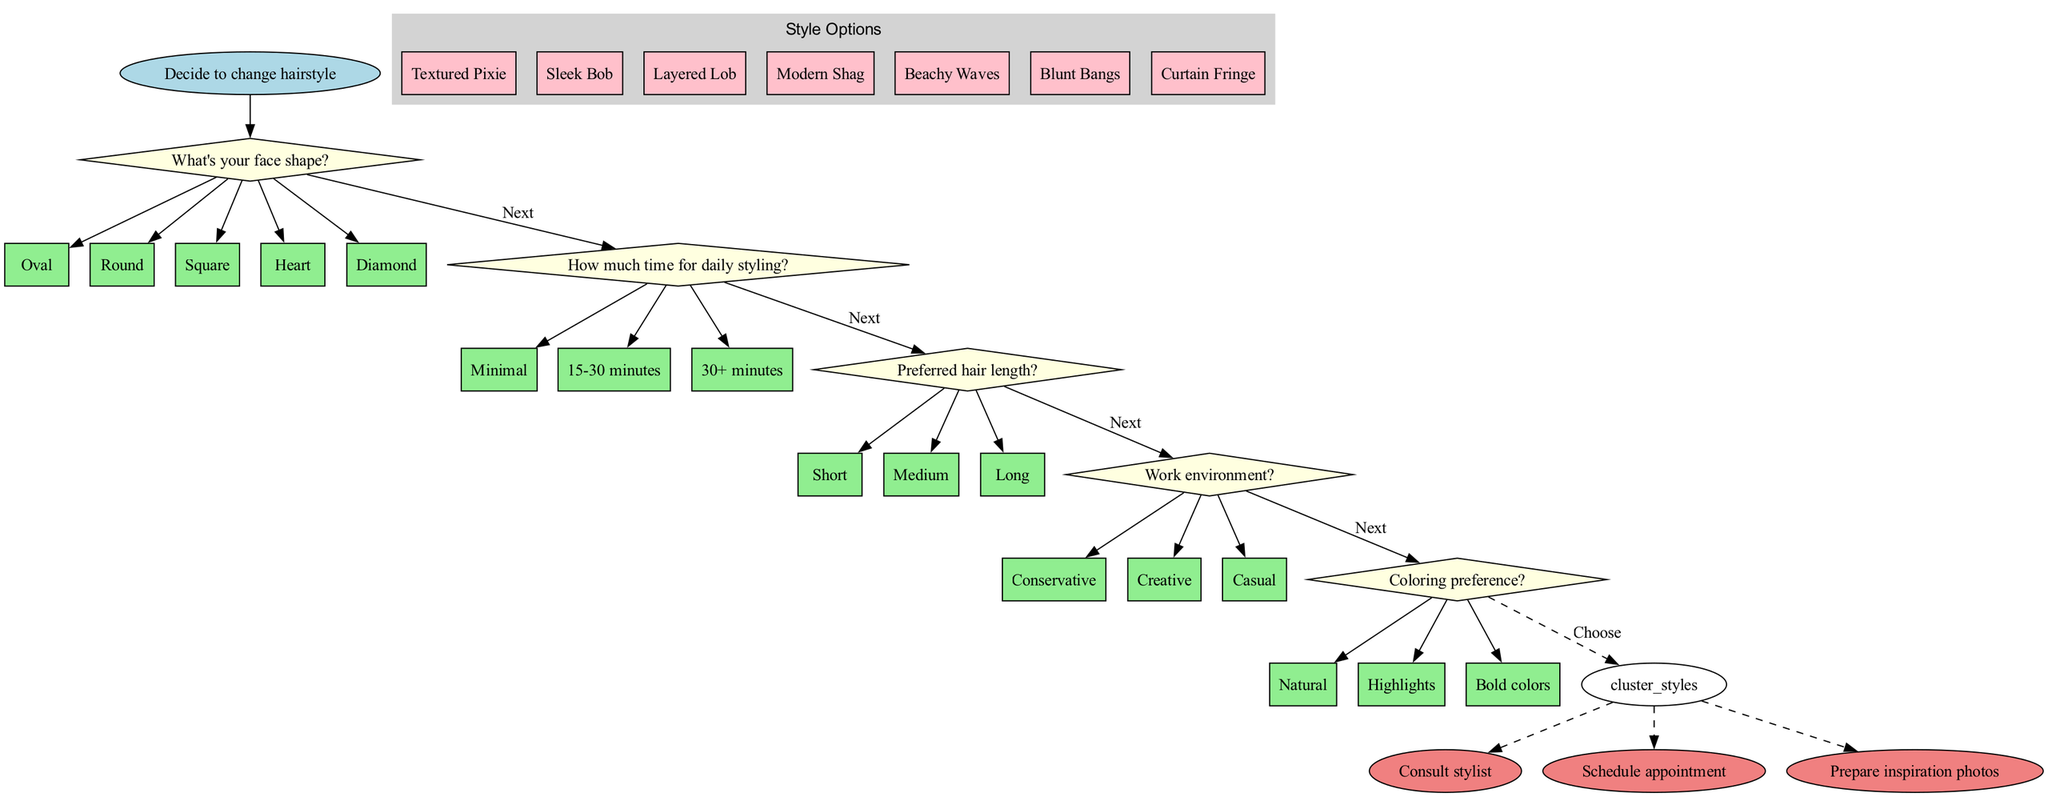What's the starting point of the flowchart? The starting point is represented by the node labeled "Decide to change hairstyle." This is identified as the first node from which all decision-making branches arise.
Answer: Decide to change hairstyle How many decision nodes are present in the diagram? There are a total of five decision nodes listed in the diagram, each representing a specific question regarding face shape, lifestyle, maintenance, hair length, and work environment.
Answer: 5 What style option is associated with the last decision node? The last decision node leads to a cluster of style options, where the decision is to "Choose" a hairstyle. However, the specific styles relate to the options identified, including ones like "Textured Pixie" and "Sleek Bob." The last decision node does not directly correspond to a single hairstyle but rather leads to the style options in general.
Answer: N/A Which decision node asks about the amount of time for daily styling? The decision node titled "How much time for daily styling?" specifically addresses this aspect, making it clear that it follows the initial question about face shape. This can be tracked through the flow from the starting node down to this specific decision.
Answer: How much time for daily styling? What are the three end nodes of the diagram? The end nodes listed in the diagram are "Consult stylist," "Schedule appointment," and "Prepare inspiration photos." Each of these represents a final step that may be taken after making hairstyle decisions based on the earlier choices.
Answer: Consult stylist, Schedule appointment, Prepare inspiration photos What type of questions do the decision nodes primarily represent? The decision nodes represent preference-based questions that guide the user through personal choices regarding their hairstyle, focusing on factors such as face shape and maintenance requirements. Each node leads to further options or clarifications based on the prior answers.
Answer: Preference-based questions How does the flow from the face shape decision connect to the styling options? The flow connects from the face shape decision node to subsequent decision nodes, as each decision guides the user through a series of choices, ultimately directing them to the style options cluster upon completing the last decision node. This structured approach ensures relevant styling options based on previously made decisions.
Answer: Through sequential decisions to style options Which color preference is listed as an option in the diagram? The color preference decision offers options, which include "Natural," "Highlights," and "Bold colors." Each of these preferences is noted as a valid choice for users determining their desired hair color as part of their new hairstyle decision process.
Answer: Natural, Highlights, Bold colors 